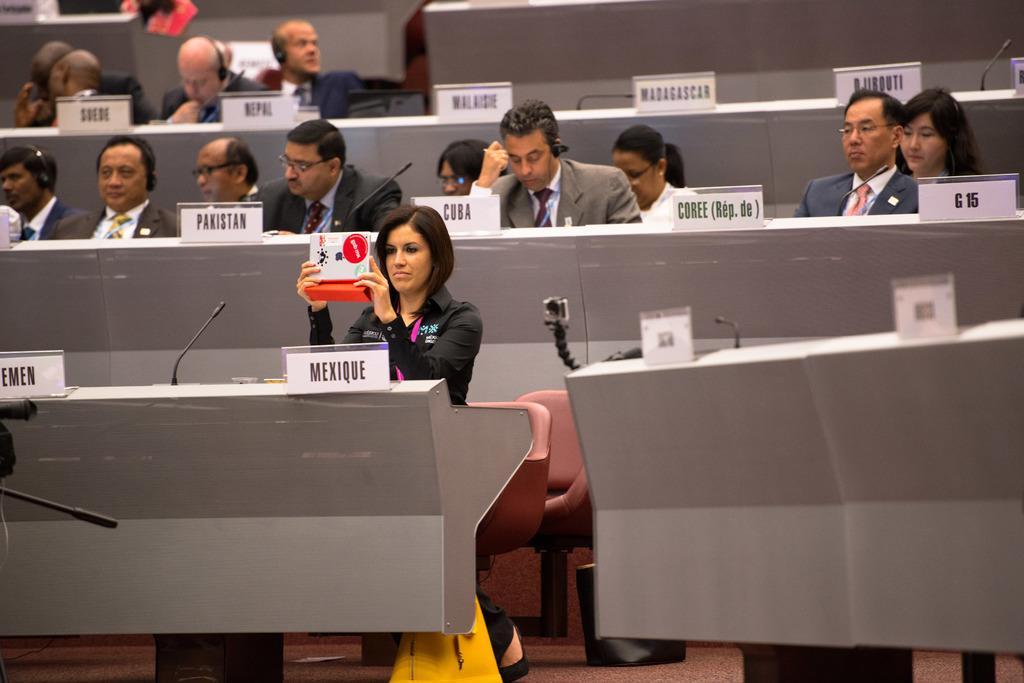Can you describe this image briefly? Group of people sitting on the chairs and this person holding object. We can see microphones,name boards on the tables. This is floor. 